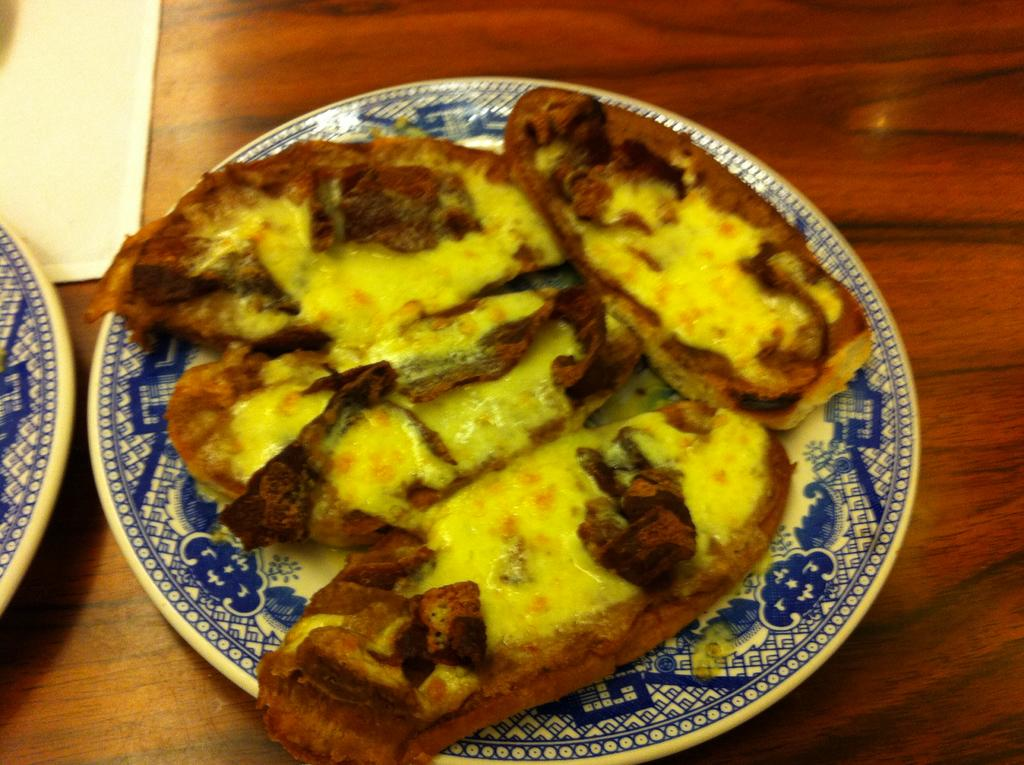What is on the plate that is visible in the image? There is a food item on the plate in the image. Where is the plate located in the image? The plate is placed on a table in the image. What is the color of the object on the table? The object on the table is white. How does the tongue interact with the food item on the plate in the image? There is no tongue present in the image, so it is not possible to determine how it might interact with the food item. 